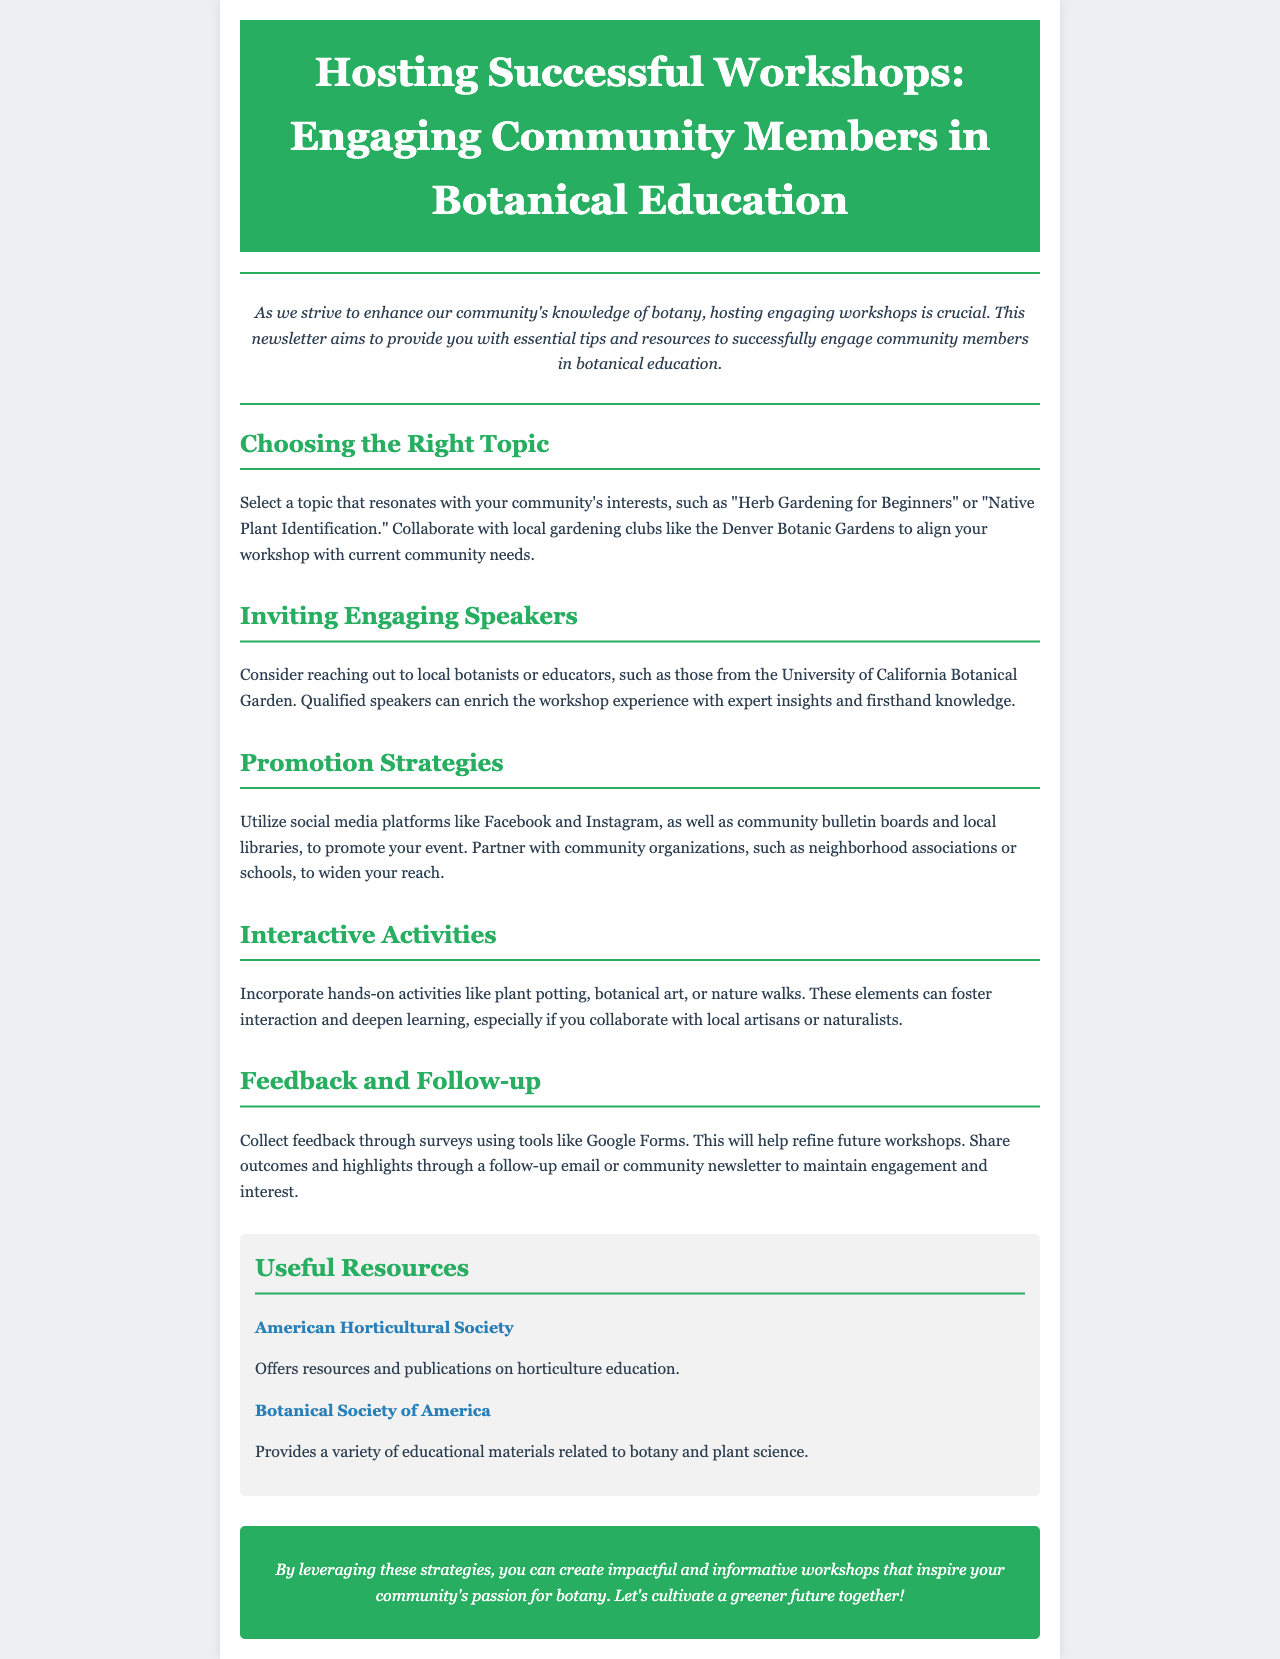what is the title of the newsletter? The title of the newsletter is located in the header section of the document, which states "Hosting Successful Workshops: Engaging Community Members in Botanical Education."
Answer: Hosting Successful Workshops: Engaging Community Members in Botanical Education what is a suggested workshop topic? The document mentions specific themes in the section on choosing the right topic, such as "Herb Gardening for Beginners."
Answer: Herb Gardening for Beginners which organization is mentioned for collaboration on workshop topics? The newsletter suggests collaborating with local gardening clubs to align with community needs, specifically mentioning the Denver Botanic Gardens.
Answer: Denver Botanic Gardens what interactive activity is recommended? In the section about interactive activities, the document suggests incorporating hands-on activities such as plant potting.
Answer: plant potting how can feedback be collected after the workshop? The document describes collecting feedback through surveys and mentions a specific tool for this purpose, which is Google Forms.
Answer: Google Forms which resources are provided in the newsletter? The resources section lists organizations that offer educational materials, including the American Horticultural Society and the Botanical Society of America.
Answer: American Horticultural Society, Botanical Society of America what is a primary method for promoting the event? The document highlights the use of social media platforms as a major promotion strategy for events.
Answer: social media what type of follow-up is suggested after the workshop? The newsletter recommends sharing outcomes and highlights through a follow-up email or community newsletter to maintain engagement.
Answer: follow-up email or community newsletter 